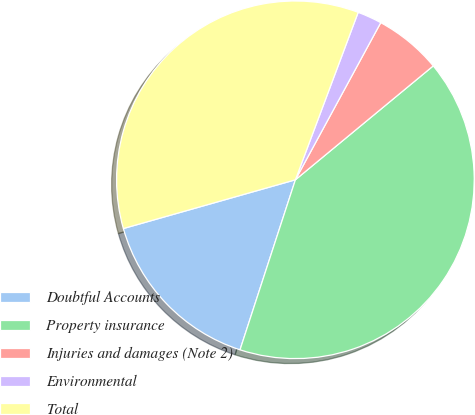<chart> <loc_0><loc_0><loc_500><loc_500><pie_chart><fcel>Doubtful Accounts<fcel>Property insurance<fcel>Injuries and damages (Note 2)<fcel>Environmental<fcel>Total<nl><fcel>15.59%<fcel>41.0%<fcel>6.09%<fcel>2.21%<fcel>35.1%<nl></chart> 